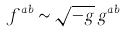<formula> <loc_0><loc_0><loc_500><loc_500>f ^ { a b } \sim \sqrt { - g } \, g ^ { a b }</formula> 